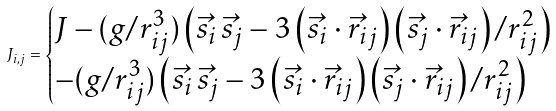<formula> <loc_0><loc_0><loc_500><loc_500>J _ { i , j } = \begin{cases} J - ( g / r _ { i j } ^ { 3 } ) \left ( \vec { s } _ { i } \, \vec { s } _ { j } - 3 \left ( \vec { s } _ { i } \cdot \vec { r } _ { i j } \right ) \left ( \vec { s } _ { j } \cdot \vec { r } _ { i j } \right ) / r _ { i j } ^ { 2 } \right ) \\ - ( g / r _ { i j } ^ { 3 } ) \left ( \vec { s } _ { i } \, \vec { s } _ { j } - 3 \left ( \vec { s } _ { i } \cdot \vec { r } _ { i j } \right ) \left ( \vec { s } _ { j } \cdot \vec { r } _ { i j } \right ) / r _ { i j } ^ { 2 } \right ) \end{cases}</formula> 